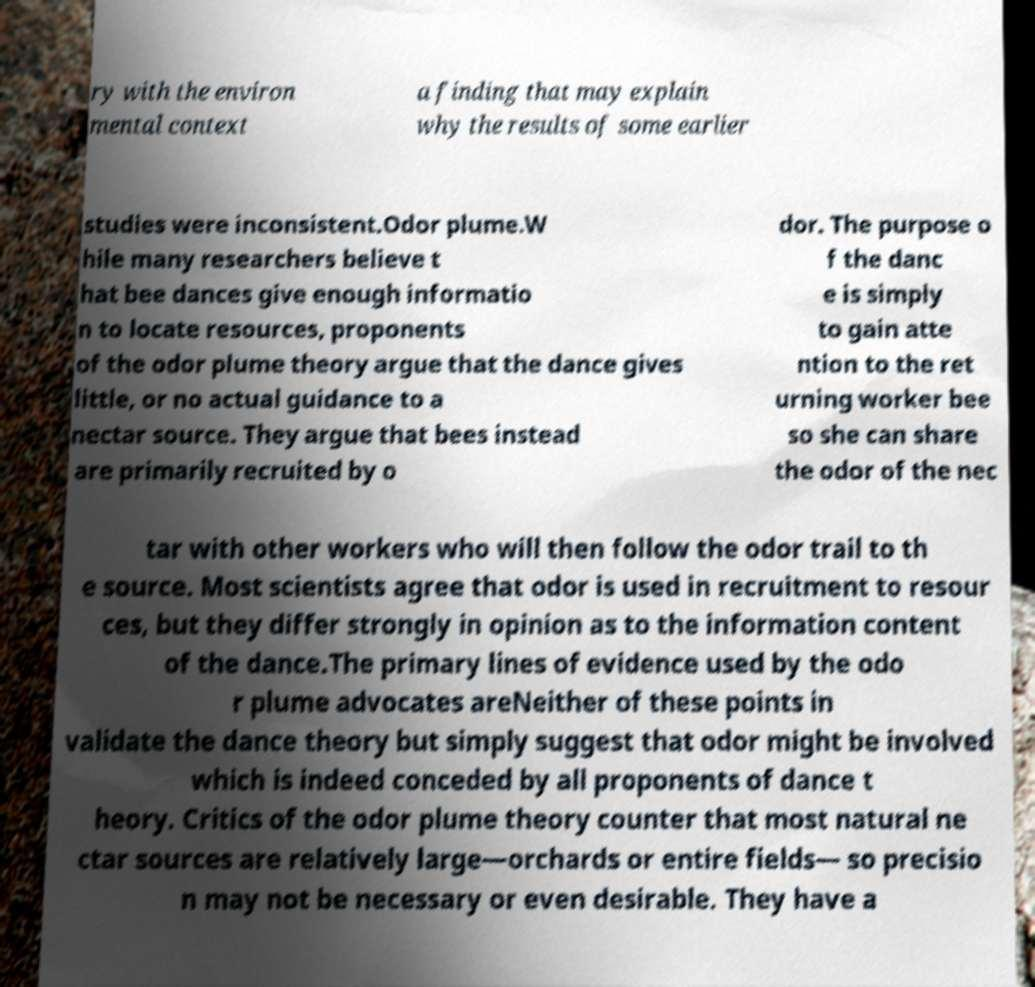Could you extract and type out the text from this image? ry with the environ mental context a finding that may explain why the results of some earlier studies were inconsistent.Odor plume.W hile many researchers believe t hat bee dances give enough informatio n to locate resources, proponents of the odor plume theory argue that the dance gives little, or no actual guidance to a nectar source. They argue that bees instead are primarily recruited by o dor. The purpose o f the danc e is simply to gain atte ntion to the ret urning worker bee so she can share the odor of the nec tar with other workers who will then follow the odor trail to th e source. Most scientists agree that odor is used in recruitment to resour ces, but they differ strongly in opinion as to the information content of the dance.The primary lines of evidence used by the odo r plume advocates areNeither of these points in validate the dance theory but simply suggest that odor might be involved which is indeed conceded by all proponents of dance t heory. Critics of the odor plume theory counter that most natural ne ctar sources are relatively large—orchards or entire fields— so precisio n may not be necessary or even desirable. They have a 